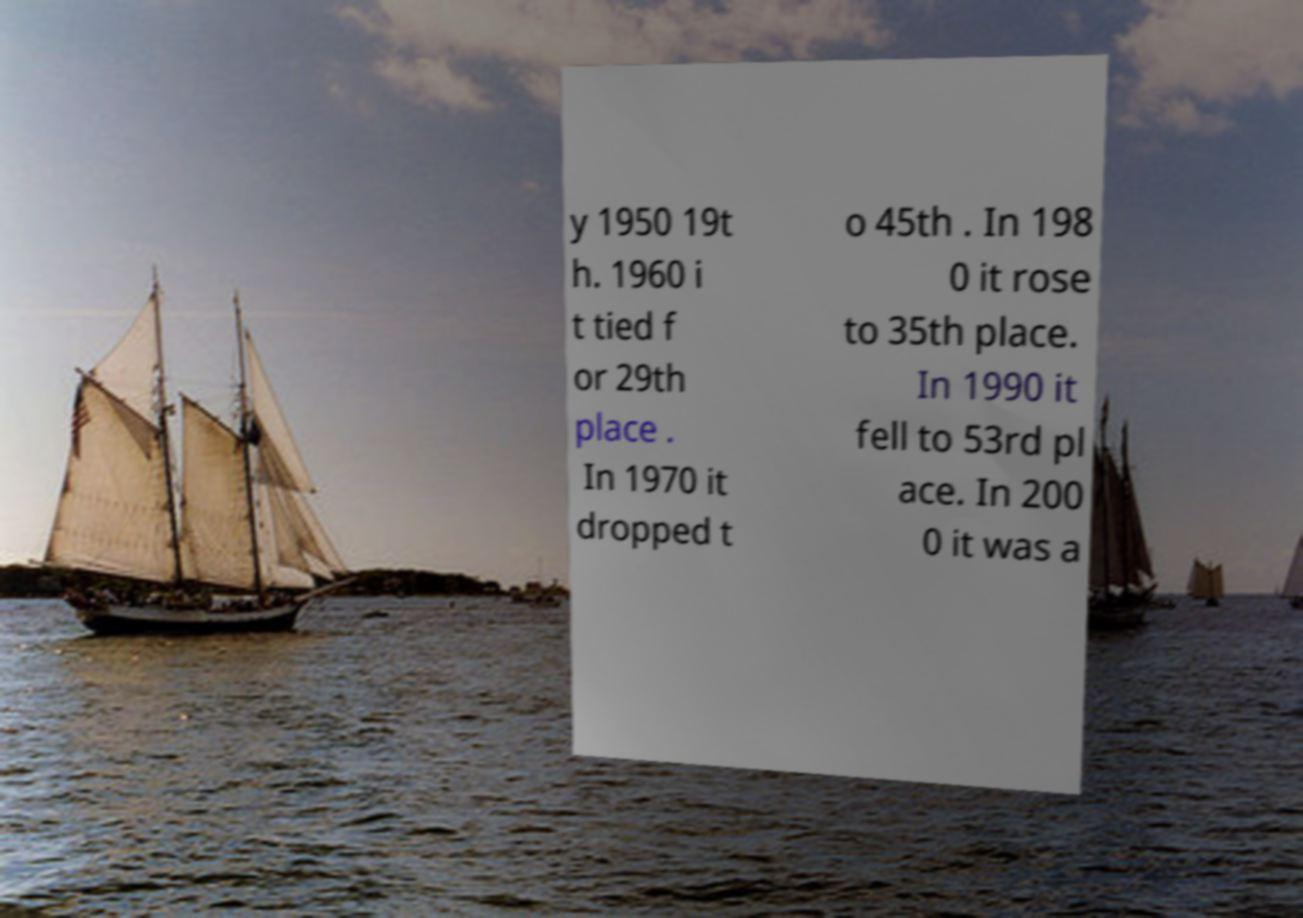Can you read and provide the text displayed in the image?This photo seems to have some interesting text. Can you extract and type it out for me? y 1950 19t h. 1960 i t tied f or 29th place . In 1970 it dropped t o 45th . In 198 0 it rose to 35th place. In 1990 it fell to 53rd pl ace. In 200 0 it was a 